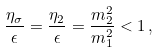<formula> <loc_0><loc_0><loc_500><loc_500>\frac { \eta _ { \sigma } } { \epsilon } = \frac { \eta _ { 2 } } { \epsilon } = \frac { m _ { 2 } ^ { 2 } } { m _ { 1 } ^ { 2 } } < 1 \, ,</formula> 